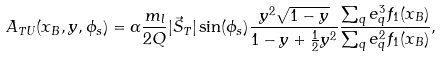<formula> <loc_0><loc_0><loc_500><loc_500>A _ { T U } ( x _ { B } , y , \phi _ { s } ) = \alpha \frac { m _ { l } } { 2 Q } | \vec { S } _ { T } | \sin ( \phi _ { s } ) \frac { y ^ { 2 } \sqrt { 1 - y } } { 1 - y + \frac { 1 } { 2 } y ^ { 2 } } \frac { \sum _ { q } e _ { q } ^ { 3 } f _ { 1 } ( x _ { B } ) } { \sum _ { q } e _ { q } ^ { 2 } f _ { 1 } ( x _ { B } ) } ,</formula> 